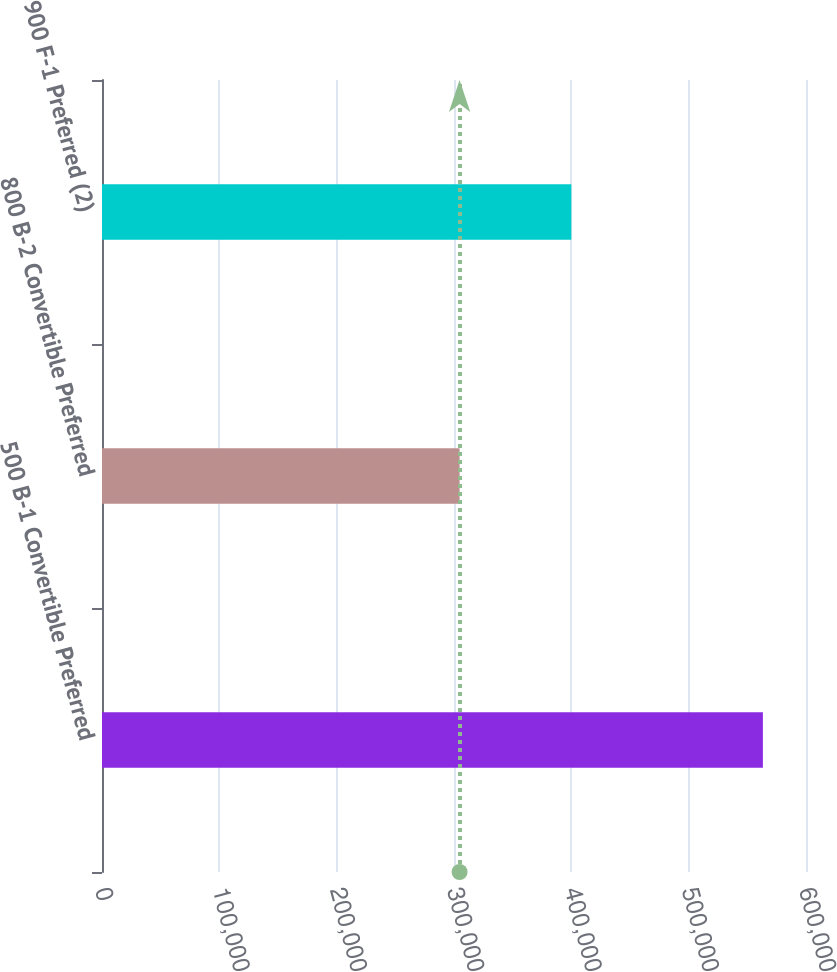Convert chart. <chart><loc_0><loc_0><loc_500><loc_500><bar_chart><fcel>500 B-1 Convertible Preferred<fcel>800 B-2 Convertible Preferred<fcel>900 F-1 Preferred (2)<nl><fcel>563263<fcel>304761<fcel>400000<nl></chart> 